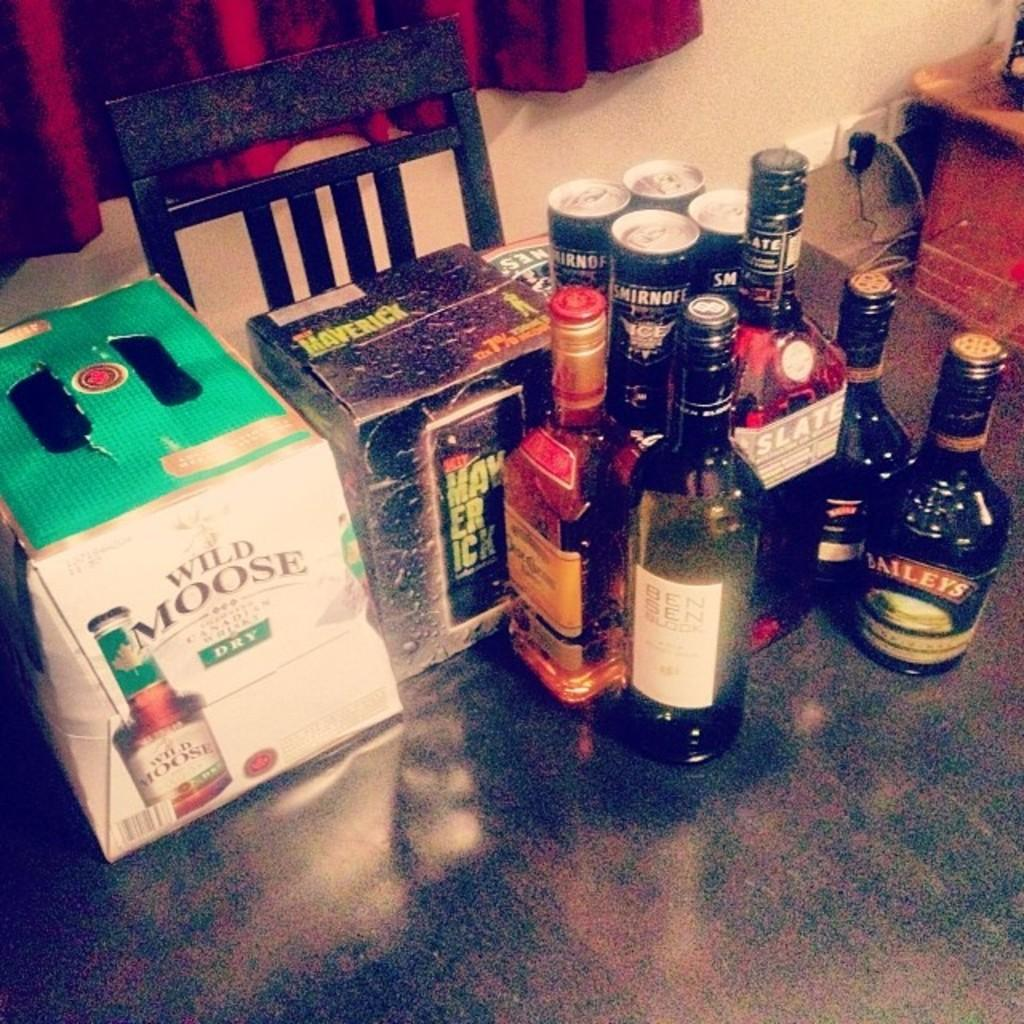Provide a one-sentence caption for the provided image. A row of liquor bottles are by a box of beer that says Wild Moose. 